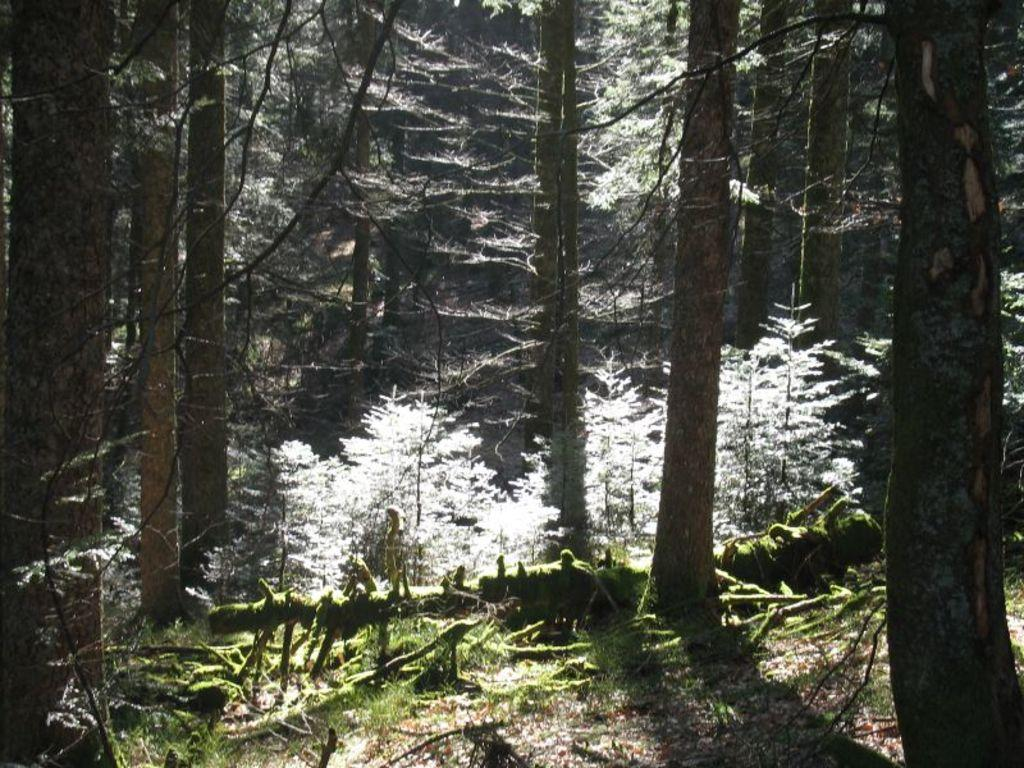What type of vegetation can be seen in the image? There are trees in the image. What is the ground made of in the image? Soil is visible at the bottom of the image. What else can be found at the bottom of the image? Dry leaves are present at the bottom of the image. What direction is the hall facing in the image? There is no hall present in the image. What type of wood can be seen in the image? There is no wood present in the image. 